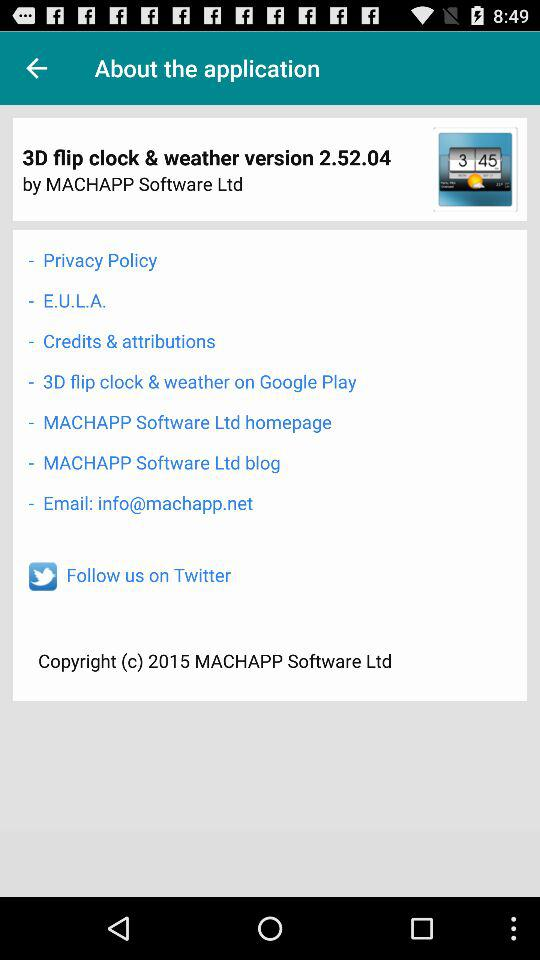What is the email address? The email address is info@machapp.net. 